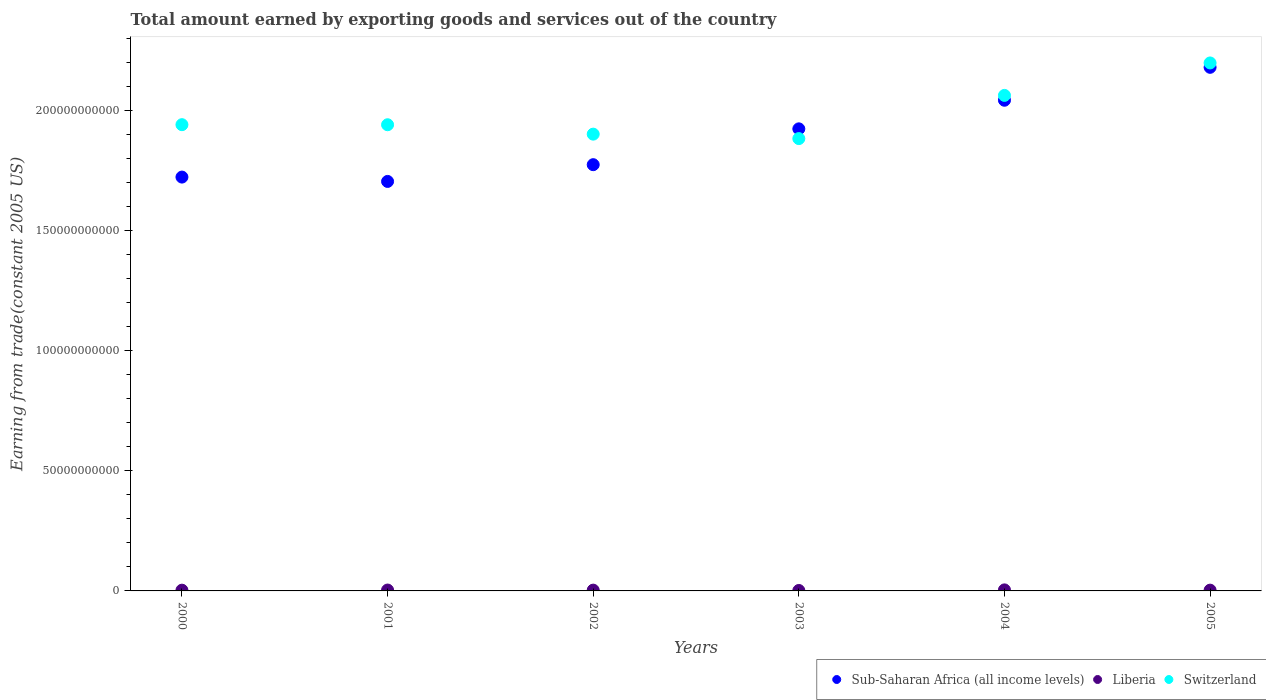What is the total amount earned by exporting goods and services in Switzerland in 2003?
Give a very brief answer. 1.88e+11. Across all years, what is the maximum total amount earned by exporting goods and services in Liberia?
Provide a short and direct response. 4.31e+08. Across all years, what is the minimum total amount earned by exporting goods and services in Switzerland?
Offer a very short reply. 1.88e+11. In which year was the total amount earned by exporting goods and services in Switzerland maximum?
Make the answer very short. 2005. In which year was the total amount earned by exporting goods and services in Switzerland minimum?
Keep it short and to the point. 2003. What is the total total amount earned by exporting goods and services in Liberia in the graph?
Offer a terse response. 1.95e+09. What is the difference between the total amount earned by exporting goods and services in Switzerland in 2002 and that in 2004?
Give a very brief answer. -1.61e+1. What is the difference between the total amount earned by exporting goods and services in Sub-Saharan Africa (all income levels) in 2001 and the total amount earned by exporting goods and services in Switzerland in 2000?
Your answer should be very brief. -2.36e+1. What is the average total amount earned by exporting goods and services in Sub-Saharan Africa (all income levels) per year?
Your answer should be compact. 1.89e+11. In the year 2001, what is the difference between the total amount earned by exporting goods and services in Liberia and total amount earned by exporting goods and services in Sub-Saharan Africa (all income levels)?
Your answer should be compact. -1.70e+11. In how many years, is the total amount earned by exporting goods and services in Sub-Saharan Africa (all income levels) greater than 60000000000 US$?
Keep it short and to the point. 6. What is the ratio of the total amount earned by exporting goods and services in Liberia in 2001 to that in 2003?
Provide a succinct answer. 1.96. Is the total amount earned by exporting goods and services in Liberia in 2002 less than that in 2005?
Your answer should be very brief. No. What is the difference between the highest and the second highest total amount earned by exporting goods and services in Sub-Saharan Africa (all income levels)?
Your answer should be very brief. 1.37e+1. What is the difference between the highest and the lowest total amount earned by exporting goods and services in Liberia?
Provide a short and direct response. 2.45e+08. Is the sum of the total amount earned by exporting goods and services in Switzerland in 2002 and 2004 greater than the maximum total amount earned by exporting goods and services in Sub-Saharan Africa (all income levels) across all years?
Your answer should be very brief. Yes. Does the total amount earned by exporting goods and services in Sub-Saharan Africa (all income levels) monotonically increase over the years?
Offer a very short reply. No. Is the total amount earned by exporting goods and services in Switzerland strictly greater than the total amount earned by exporting goods and services in Sub-Saharan Africa (all income levels) over the years?
Give a very brief answer. No. Is the total amount earned by exporting goods and services in Liberia strictly less than the total amount earned by exporting goods and services in Sub-Saharan Africa (all income levels) over the years?
Your response must be concise. Yes. What is the difference between two consecutive major ticks on the Y-axis?
Give a very brief answer. 5.00e+1. Where does the legend appear in the graph?
Keep it short and to the point. Bottom right. How many legend labels are there?
Give a very brief answer. 3. What is the title of the graph?
Provide a short and direct response. Total amount earned by exporting goods and services out of the country. Does "Philippines" appear as one of the legend labels in the graph?
Your answer should be compact. No. What is the label or title of the X-axis?
Your answer should be compact. Years. What is the label or title of the Y-axis?
Offer a terse response. Earning from trade(constant 2005 US). What is the Earning from trade(constant 2005 US) in Sub-Saharan Africa (all income levels) in 2000?
Provide a succinct answer. 1.72e+11. What is the Earning from trade(constant 2005 US) in Liberia in 2000?
Your answer should be very brief. 3.10e+08. What is the Earning from trade(constant 2005 US) in Switzerland in 2000?
Your response must be concise. 1.94e+11. What is the Earning from trade(constant 2005 US) of Sub-Saharan Africa (all income levels) in 2001?
Offer a terse response. 1.71e+11. What is the Earning from trade(constant 2005 US) of Liberia in 2001?
Your answer should be very brief. 3.65e+08. What is the Earning from trade(constant 2005 US) in Switzerland in 2001?
Provide a short and direct response. 1.94e+11. What is the Earning from trade(constant 2005 US) of Sub-Saharan Africa (all income levels) in 2002?
Your response must be concise. 1.77e+11. What is the Earning from trade(constant 2005 US) in Liberia in 2002?
Provide a succinct answer. 3.28e+08. What is the Earning from trade(constant 2005 US) in Switzerland in 2002?
Provide a succinct answer. 1.90e+11. What is the Earning from trade(constant 2005 US) of Sub-Saharan Africa (all income levels) in 2003?
Provide a succinct answer. 1.92e+11. What is the Earning from trade(constant 2005 US) of Liberia in 2003?
Provide a succinct answer. 1.86e+08. What is the Earning from trade(constant 2005 US) in Switzerland in 2003?
Give a very brief answer. 1.88e+11. What is the Earning from trade(constant 2005 US) of Sub-Saharan Africa (all income levels) in 2004?
Offer a terse response. 2.04e+11. What is the Earning from trade(constant 2005 US) of Liberia in 2004?
Your response must be concise. 4.31e+08. What is the Earning from trade(constant 2005 US) of Switzerland in 2004?
Offer a very short reply. 2.06e+11. What is the Earning from trade(constant 2005 US) of Sub-Saharan Africa (all income levels) in 2005?
Provide a succinct answer. 2.18e+11. What is the Earning from trade(constant 2005 US) of Liberia in 2005?
Offer a terse response. 3.25e+08. What is the Earning from trade(constant 2005 US) of Switzerland in 2005?
Provide a short and direct response. 2.20e+11. Across all years, what is the maximum Earning from trade(constant 2005 US) of Sub-Saharan Africa (all income levels)?
Provide a succinct answer. 2.18e+11. Across all years, what is the maximum Earning from trade(constant 2005 US) in Liberia?
Ensure brevity in your answer.  4.31e+08. Across all years, what is the maximum Earning from trade(constant 2005 US) of Switzerland?
Ensure brevity in your answer.  2.20e+11. Across all years, what is the minimum Earning from trade(constant 2005 US) in Sub-Saharan Africa (all income levels)?
Make the answer very short. 1.71e+11. Across all years, what is the minimum Earning from trade(constant 2005 US) of Liberia?
Provide a succinct answer. 1.86e+08. Across all years, what is the minimum Earning from trade(constant 2005 US) of Switzerland?
Keep it short and to the point. 1.88e+11. What is the total Earning from trade(constant 2005 US) of Sub-Saharan Africa (all income levels) in the graph?
Keep it short and to the point. 1.14e+12. What is the total Earning from trade(constant 2005 US) in Liberia in the graph?
Provide a succinct answer. 1.95e+09. What is the total Earning from trade(constant 2005 US) in Switzerland in the graph?
Your response must be concise. 1.19e+12. What is the difference between the Earning from trade(constant 2005 US) of Sub-Saharan Africa (all income levels) in 2000 and that in 2001?
Provide a short and direct response. 1.81e+09. What is the difference between the Earning from trade(constant 2005 US) of Liberia in 2000 and that in 2001?
Make the answer very short. -5.56e+07. What is the difference between the Earning from trade(constant 2005 US) in Switzerland in 2000 and that in 2001?
Offer a very short reply. 2.98e+07. What is the difference between the Earning from trade(constant 2005 US) of Sub-Saharan Africa (all income levels) in 2000 and that in 2002?
Your response must be concise. -5.17e+09. What is the difference between the Earning from trade(constant 2005 US) in Liberia in 2000 and that in 2002?
Keep it short and to the point. -1.86e+07. What is the difference between the Earning from trade(constant 2005 US) of Switzerland in 2000 and that in 2002?
Keep it short and to the point. 3.94e+09. What is the difference between the Earning from trade(constant 2005 US) in Sub-Saharan Africa (all income levels) in 2000 and that in 2003?
Ensure brevity in your answer.  -2.01e+1. What is the difference between the Earning from trade(constant 2005 US) of Liberia in 2000 and that in 2003?
Provide a short and direct response. 1.24e+08. What is the difference between the Earning from trade(constant 2005 US) of Switzerland in 2000 and that in 2003?
Your response must be concise. 5.79e+09. What is the difference between the Earning from trade(constant 2005 US) in Sub-Saharan Africa (all income levels) in 2000 and that in 2004?
Make the answer very short. -3.20e+1. What is the difference between the Earning from trade(constant 2005 US) in Liberia in 2000 and that in 2004?
Ensure brevity in your answer.  -1.21e+08. What is the difference between the Earning from trade(constant 2005 US) of Switzerland in 2000 and that in 2004?
Provide a succinct answer. -1.22e+1. What is the difference between the Earning from trade(constant 2005 US) of Sub-Saharan Africa (all income levels) in 2000 and that in 2005?
Give a very brief answer. -4.57e+1. What is the difference between the Earning from trade(constant 2005 US) in Liberia in 2000 and that in 2005?
Provide a succinct answer. -1.52e+07. What is the difference between the Earning from trade(constant 2005 US) of Switzerland in 2000 and that in 2005?
Your answer should be very brief. -2.57e+1. What is the difference between the Earning from trade(constant 2005 US) in Sub-Saharan Africa (all income levels) in 2001 and that in 2002?
Ensure brevity in your answer.  -6.98e+09. What is the difference between the Earning from trade(constant 2005 US) of Liberia in 2001 and that in 2002?
Provide a short and direct response. 3.70e+07. What is the difference between the Earning from trade(constant 2005 US) of Switzerland in 2001 and that in 2002?
Your response must be concise. 3.91e+09. What is the difference between the Earning from trade(constant 2005 US) in Sub-Saharan Africa (all income levels) in 2001 and that in 2003?
Your response must be concise. -2.19e+1. What is the difference between the Earning from trade(constant 2005 US) of Liberia in 2001 and that in 2003?
Your response must be concise. 1.79e+08. What is the difference between the Earning from trade(constant 2005 US) of Switzerland in 2001 and that in 2003?
Offer a terse response. 5.76e+09. What is the difference between the Earning from trade(constant 2005 US) of Sub-Saharan Africa (all income levels) in 2001 and that in 2004?
Keep it short and to the point. -3.38e+1. What is the difference between the Earning from trade(constant 2005 US) of Liberia in 2001 and that in 2004?
Your answer should be compact. -6.53e+07. What is the difference between the Earning from trade(constant 2005 US) of Switzerland in 2001 and that in 2004?
Provide a succinct answer. -1.22e+1. What is the difference between the Earning from trade(constant 2005 US) in Sub-Saharan Africa (all income levels) in 2001 and that in 2005?
Ensure brevity in your answer.  -4.75e+1. What is the difference between the Earning from trade(constant 2005 US) in Liberia in 2001 and that in 2005?
Offer a terse response. 4.04e+07. What is the difference between the Earning from trade(constant 2005 US) of Switzerland in 2001 and that in 2005?
Provide a short and direct response. -2.57e+1. What is the difference between the Earning from trade(constant 2005 US) of Sub-Saharan Africa (all income levels) in 2002 and that in 2003?
Offer a terse response. -1.49e+1. What is the difference between the Earning from trade(constant 2005 US) of Liberia in 2002 and that in 2003?
Ensure brevity in your answer.  1.42e+08. What is the difference between the Earning from trade(constant 2005 US) in Switzerland in 2002 and that in 2003?
Make the answer very short. 1.85e+09. What is the difference between the Earning from trade(constant 2005 US) in Sub-Saharan Africa (all income levels) in 2002 and that in 2004?
Make the answer very short. -2.68e+1. What is the difference between the Earning from trade(constant 2005 US) of Liberia in 2002 and that in 2004?
Ensure brevity in your answer.  -1.02e+08. What is the difference between the Earning from trade(constant 2005 US) in Switzerland in 2002 and that in 2004?
Offer a terse response. -1.61e+1. What is the difference between the Earning from trade(constant 2005 US) in Sub-Saharan Africa (all income levels) in 2002 and that in 2005?
Give a very brief answer. -4.05e+1. What is the difference between the Earning from trade(constant 2005 US) of Liberia in 2002 and that in 2005?
Your answer should be very brief. 3.39e+06. What is the difference between the Earning from trade(constant 2005 US) in Switzerland in 2002 and that in 2005?
Provide a short and direct response. -2.96e+1. What is the difference between the Earning from trade(constant 2005 US) in Sub-Saharan Africa (all income levels) in 2003 and that in 2004?
Provide a short and direct response. -1.19e+1. What is the difference between the Earning from trade(constant 2005 US) in Liberia in 2003 and that in 2004?
Ensure brevity in your answer.  -2.45e+08. What is the difference between the Earning from trade(constant 2005 US) in Switzerland in 2003 and that in 2004?
Offer a terse response. -1.80e+1. What is the difference between the Earning from trade(constant 2005 US) in Sub-Saharan Africa (all income levels) in 2003 and that in 2005?
Keep it short and to the point. -2.56e+1. What is the difference between the Earning from trade(constant 2005 US) of Liberia in 2003 and that in 2005?
Offer a terse response. -1.39e+08. What is the difference between the Earning from trade(constant 2005 US) in Switzerland in 2003 and that in 2005?
Keep it short and to the point. -3.15e+1. What is the difference between the Earning from trade(constant 2005 US) in Sub-Saharan Africa (all income levels) in 2004 and that in 2005?
Your answer should be very brief. -1.37e+1. What is the difference between the Earning from trade(constant 2005 US) of Liberia in 2004 and that in 2005?
Ensure brevity in your answer.  1.06e+08. What is the difference between the Earning from trade(constant 2005 US) of Switzerland in 2004 and that in 2005?
Give a very brief answer. -1.35e+1. What is the difference between the Earning from trade(constant 2005 US) in Sub-Saharan Africa (all income levels) in 2000 and the Earning from trade(constant 2005 US) in Liberia in 2001?
Keep it short and to the point. 1.72e+11. What is the difference between the Earning from trade(constant 2005 US) of Sub-Saharan Africa (all income levels) in 2000 and the Earning from trade(constant 2005 US) of Switzerland in 2001?
Your answer should be compact. -2.18e+1. What is the difference between the Earning from trade(constant 2005 US) of Liberia in 2000 and the Earning from trade(constant 2005 US) of Switzerland in 2001?
Your answer should be compact. -1.94e+11. What is the difference between the Earning from trade(constant 2005 US) of Sub-Saharan Africa (all income levels) in 2000 and the Earning from trade(constant 2005 US) of Liberia in 2002?
Give a very brief answer. 1.72e+11. What is the difference between the Earning from trade(constant 2005 US) in Sub-Saharan Africa (all income levels) in 2000 and the Earning from trade(constant 2005 US) in Switzerland in 2002?
Keep it short and to the point. -1.79e+1. What is the difference between the Earning from trade(constant 2005 US) of Liberia in 2000 and the Earning from trade(constant 2005 US) of Switzerland in 2002?
Offer a very short reply. -1.90e+11. What is the difference between the Earning from trade(constant 2005 US) of Sub-Saharan Africa (all income levels) in 2000 and the Earning from trade(constant 2005 US) of Liberia in 2003?
Provide a succinct answer. 1.72e+11. What is the difference between the Earning from trade(constant 2005 US) of Sub-Saharan Africa (all income levels) in 2000 and the Earning from trade(constant 2005 US) of Switzerland in 2003?
Give a very brief answer. -1.60e+1. What is the difference between the Earning from trade(constant 2005 US) of Liberia in 2000 and the Earning from trade(constant 2005 US) of Switzerland in 2003?
Your response must be concise. -1.88e+11. What is the difference between the Earning from trade(constant 2005 US) of Sub-Saharan Africa (all income levels) in 2000 and the Earning from trade(constant 2005 US) of Liberia in 2004?
Offer a very short reply. 1.72e+11. What is the difference between the Earning from trade(constant 2005 US) of Sub-Saharan Africa (all income levels) in 2000 and the Earning from trade(constant 2005 US) of Switzerland in 2004?
Give a very brief answer. -3.40e+1. What is the difference between the Earning from trade(constant 2005 US) in Liberia in 2000 and the Earning from trade(constant 2005 US) in Switzerland in 2004?
Your response must be concise. -2.06e+11. What is the difference between the Earning from trade(constant 2005 US) in Sub-Saharan Africa (all income levels) in 2000 and the Earning from trade(constant 2005 US) in Liberia in 2005?
Make the answer very short. 1.72e+11. What is the difference between the Earning from trade(constant 2005 US) in Sub-Saharan Africa (all income levels) in 2000 and the Earning from trade(constant 2005 US) in Switzerland in 2005?
Your answer should be compact. -4.75e+1. What is the difference between the Earning from trade(constant 2005 US) in Liberia in 2000 and the Earning from trade(constant 2005 US) in Switzerland in 2005?
Provide a short and direct response. -2.20e+11. What is the difference between the Earning from trade(constant 2005 US) in Sub-Saharan Africa (all income levels) in 2001 and the Earning from trade(constant 2005 US) in Liberia in 2002?
Ensure brevity in your answer.  1.70e+11. What is the difference between the Earning from trade(constant 2005 US) of Sub-Saharan Africa (all income levels) in 2001 and the Earning from trade(constant 2005 US) of Switzerland in 2002?
Give a very brief answer. -1.97e+1. What is the difference between the Earning from trade(constant 2005 US) in Liberia in 2001 and the Earning from trade(constant 2005 US) in Switzerland in 2002?
Offer a terse response. -1.90e+11. What is the difference between the Earning from trade(constant 2005 US) of Sub-Saharan Africa (all income levels) in 2001 and the Earning from trade(constant 2005 US) of Liberia in 2003?
Provide a short and direct response. 1.70e+11. What is the difference between the Earning from trade(constant 2005 US) in Sub-Saharan Africa (all income levels) in 2001 and the Earning from trade(constant 2005 US) in Switzerland in 2003?
Make the answer very short. -1.78e+1. What is the difference between the Earning from trade(constant 2005 US) of Liberia in 2001 and the Earning from trade(constant 2005 US) of Switzerland in 2003?
Your answer should be very brief. -1.88e+11. What is the difference between the Earning from trade(constant 2005 US) of Sub-Saharan Africa (all income levels) in 2001 and the Earning from trade(constant 2005 US) of Liberia in 2004?
Your response must be concise. 1.70e+11. What is the difference between the Earning from trade(constant 2005 US) of Sub-Saharan Africa (all income levels) in 2001 and the Earning from trade(constant 2005 US) of Switzerland in 2004?
Your response must be concise. -3.58e+1. What is the difference between the Earning from trade(constant 2005 US) in Liberia in 2001 and the Earning from trade(constant 2005 US) in Switzerland in 2004?
Your answer should be very brief. -2.06e+11. What is the difference between the Earning from trade(constant 2005 US) of Sub-Saharan Africa (all income levels) in 2001 and the Earning from trade(constant 2005 US) of Liberia in 2005?
Keep it short and to the point. 1.70e+11. What is the difference between the Earning from trade(constant 2005 US) in Sub-Saharan Africa (all income levels) in 2001 and the Earning from trade(constant 2005 US) in Switzerland in 2005?
Provide a succinct answer. -4.93e+1. What is the difference between the Earning from trade(constant 2005 US) of Liberia in 2001 and the Earning from trade(constant 2005 US) of Switzerland in 2005?
Offer a very short reply. -2.19e+11. What is the difference between the Earning from trade(constant 2005 US) of Sub-Saharan Africa (all income levels) in 2002 and the Earning from trade(constant 2005 US) of Liberia in 2003?
Offer a very short reply. 1.77e+11. What is the difference between the Earning from trade(constant 2005 US) of Sub-Saharan Africa (all income levels) in 2002 and the Earning from trade(constant 2005 US) of Switzerland in 2003?
Give a very brief answer. -1.09e+1. What is the difference between the Earning from trade(constant 2005 US) of Liberia in 2002 and the Earning from trade(constant 2005 US) of Switzerland in 2003?
Provide a succinct answer. -1.88e+11. What is the difference between the Earning from trade(constant 2005 US) in Sub-Saharan Africa (all income levels) in 2002 and the Earning from trade(constant 2005 US) in Liberia in 2004?
Your answer should be compact. 1.77e+11. What is the difference between the Earning from trade(constant 2005 US) of Sub-Saharan Africa (all income levels) in 2002 and the Earning from trade(constant 2005 US) of Switzerland in 2004?
Keep it short and to the point. -2.88e+1. What is the difference between the Earning from trade(constant 2005 US) in Liberia in 2002 and the Earning from trade(constant 2005 US) in Switzerland in 2004?
Offer a very short reply. -2.06e+11. What is the difference between the Earning from trade(constant 2005 US) in Sub-Saharan Africa (all income levels) in 2002 and the Earning from trade(constant 2005 US) in Liberia in 2005?
Provide a short and direct response. 1.77e+11. What is the difference between the Earning from trade(constant 2005 US) in Sub-Saharan Africa (all income levels) in 2002 and the Earning from trade(constant 2005 US) in Switzerland in 2005?
Make the answer very short. -4.24e+1. What is the difference between the Earning from trade(constant 2005 US) in Liberia in 2002 and the Earning from trade(constant 2005 US) in Switzerland in 2005?
Your answer should be compact. -2.20e+11. What is the difference between the Earning from trade(constant 2005 US) in Sub-Saharan Africa (all income levels) in 2003 and the Earning from trade(constant 2005 US) in Liberia in 2004?
Your response must be concise. 1.92e+11. What is the difference between the Earning from trade(constant 2005 US) of Sub-Saharan Africa (all income levels) in 2003 and the Earning from trade(constant 2005 US) of Switzerland in 2004?
Your answer should be very brief. -1.39e+1. What is the difference between the Earning from trade(constant 2005 US) in Liberia in 2003 and the Earning from trade(constant 2005 US) in Switzerland in 2004?
Offer a very short reply. -2.06e+11. What is the difference between the Earning from trade(constant 2005 US) in Sub-Saharan Africa (all income levels) in 2003 and the Earning from trade(constant 2005 US) in Liberia in 2005?
Give a very brief answer. 1.92e+11. What is the difference between the Earning from trade(constant 2005 US) of Sub-Saharan Africa (all income levels) in 2003 and the Earning from trade(constant 2005 US) of Switzerland in 2005?
Make the answer very short. -2.74e+1. What is the difference between the Earning from trade(constant 2005 US) of Liberia in 2003 and the Earning from trade(constant 2005 US) of Switzerland in 2005?
Your answer should be very brief. -2.20e+11. What is the difference between the Earning from trade(constant 2005 US) in Sub-Saharan Africa (all income levels) in 2004 and the Earning from trade(constant 2005 US) in Liberia in 2005?
Make the answer very short. 2.04e+11. What is the difference between the Earning from trade(constant 2005 US) in Sub-Saharan Africa (all income levels) in 2004 and the Earning from trade(constant 2005 US) in Switzerland in 2005?
Make the answer very short. -1.55e+1. What is the difference between the Earning from trade(constant 2005 US) of Liberia in 2004 and the Earning from trade(constant 2005 US) of Switzerland in 2005?
Your answer should be compact. -2.19e+11. What is the average Earning from trade(constant 2005 US) in Sub-Saharan Africa (all income levels) per year?
Keep it short and to the point. 1.89e+11. What is the average Earning from trade(constant 2005 US) of Liberia per year?
Your answer should be very brief. 3.24e+08. What is the average Earning from trade(constant 2005 US) in Switzerland per year?
Your answer should be compact. 1.99e+11. In the year 2000, what is the difference between the Earning from trade(constant 2005 US) in Sub-Saharan Africa (all income levels) and Earning from trade(constant 2005 US) in Liberia?
Your answer should be very brief. 1.72e+11. In the year 2000, what is the difference between the Earning from trade(constant 2005 US) in Sub-Saharan Africa (all income levels) and Earning from trade(constant 2005 US) in Switzerland?
Offer a very short reply. -2.18e+1. In the year 2000, what is the difference between the Earning from trade(constant 2005 US) in Liberia and Earning from trade(constant 2005 US) in Switzerland?
Keep it short and to the point. -1.94e+11. In the year 2001, what is the difference between the Earning from trade(constant 2005 US) of Sub-Saharan Africa (all income levels) and Earning from trade(constant 2005 US) of Liberia?
Make the answer very short. 1.70e+11. In the year 2001, what is the difference between the Earning from trade(constant 2005 US) of Sub-Saharan Africa (all income levels) and Earning from trade(constant 2005 US) of Switzerland?
Give a very brief answer. -2.36e+1. In the year 2001, what is the difference between the Earning from trade(constant 2005 US) in Liberia and Earning from trade(constant 2005 US) in Switzerland?
Ensure brevity in your answer.  -1.94e+11. In the year 2002, what is the difference between the Earning from trade(constant 2005 US) in Sub-Saharan Africa (all income levels) and Earning from trade(constant 2005 US) in Liberia?
Ensure brevity in your answer.  1.77e+11. In the year 2002, what is the difference between the Earning from trade(constant 2005 US) of Sub-Saharan Africa (all income levels) and Earning from trade(constant 2005 US) of Switzerland?
Keep it short and to the point. -1.27e+1. In the year 2002, what is the difference between the Earning from trade(constant 2005 US) of Liberia and Earning from trade(constant 2005 US) of Switzerland?
Your answer should be compact. -1.90e+11. In the year 2003, what is the difference between the Earning from trade(constant 2005 US) of Sub-Saharan Africa (all income levels) and Earning from trade(constant 2005 US) of Liberia?
Make the answer very short. 1.92e+11. In the year 2003, what is the difference between the Earning from trade(constant 2005 US) in Sub-Saharan Africa (all income levels) and Earning from trade(constant 2005 US) in Switzerland?
Give a very brief answer. 4.05e+09. In the year 2003, what is the difference between the Earning from trade(constant 2005 US) of Liberia and Earning from trade(constant 2005 US) of Switzerland?
Your answer should be very brief. -1.88e+11. In the year 2004, what is the difference between the Earning from trade(constant 2005 US) of Sub-Saharan Africa (all income levels) and Earning from trade(constant 2005 US) of Liberia?
Provide a short and direct response. 2.04e+11. In the year 2004, what is the difference between the Earning from trade(constant 2005 US) of Sub-Saharan Africa (all income levels) and Earning from trade(constant 2005 US) of Switzerland?
Your response must be concise. -2.02e+09. In the year 2004, what is the difference between the Earning from trade(constant 2005 US) in Liberia and Earning from trade(constant 2005 US) in Switzerland?
Ensure brevity in your answer.  -2.06e+11. In the year 2005, what is the difference between the Earning from trade(constant 2005 US) of Sub-Saharan Africa (all income levels) and Earning from trade(constant 2005 US) of Liberia?
Your answer should be compact. 2.18e+11. In the year 2005, what is the difference between the Earning from trade(constant 2005 US) in Sub-Saharan Africa (all income levels) and Earning from trade(constant 2005 US) in Switzerland?
Provide a short and direct response. -1.82e+09. In the year 2005, what is the difference between the Earning from trade(constant 2005 US) of Liberia and Earning from trade(constant 2005 US) of Switzerland?
Make the answer very short. -2.20e+11. What is the ratio of the Earning from trade(constant 2005 US) of Sub-Saharan Africa (all income levels) in 2000 to that in 2001?
Your response must be concise. 1.01. What is the ratio of the Earning from trade(constant 2005 US) of Liberia in 2000 to that in 2001?
Provide a succinct answer. 0.85. What is the ratio of the Earning from trade(constant 2005 US) of Sub-Saharan Africa (all income levels) in 2000 to that in 2002?
Provide a short and direct response. 0.97. What is the ratio of the Earning from trade(constant 2005 US) of Liberia in 2000 to that in 2002?
Ensure brevity in your answer.  0.94. What is the ratio of the Earning from trade(constant 2005 US) of Switzerland in 2000 to that in 2002?
Your answer should be compact. 1.02. What is the ratio of the Earning from trade(constant 2005 US) of Sub-Saharan Africa (all income levels) in 2000 to that in 2003?
Keep it short and to the point. 0.9. What is the ratio of the Earning from trade(constant 2005 US) in Liberia in 2000 to that in 2003?
Make the answer very short. 1.67. What is the ratio of the Earning from trade(constant 2005 US) of Switzerland in 2000 to that in 2003?
Give a very brief answer. 1.03. What is the ratio of the Earning from trade(constant 2005 US) in Sub-Saharan Africa (all income levels) in 2000 to that in 2004?
Your answer should be compact. 0.84. What is the ratio of the Earning from trade(constant 2005 US) of Liberia in 2000 to that in 2004?
Offer a very short reply. 0.72. What is the ratio of the Earning from trade(constant 2005 US) of Switzerland in 2000 to that in 2004?
Keep it short and to the point. 0.94. What is the ratio of the Earning from trade(constant 2005 US) in Sub-Saharan Africa (all income levels) in 2000 to that in 2005?
Your answer should be compact. 0.79. What is the ratio of the Earning from trade(constant 2005 US) in Liberia in 2000 to that in 2005?
Offer a very short reply. 0.95. What is the ratio of the Earning from trade(constant 2005 US) of Switzerland in 2000 to that in 2005?
Provide a short and direct response. 0.88. What is the ratio of the Earning from trade(constant 2005 US) of Sub-Saharan Africa (all income levels) in 2001 to that in 2002?
Give a very brief answer. 0.96. What is the ratio of the Earning from trade(constant 2005 US) in Liberia in 2001 to that in 2002?
Your response must be concise. 1.11. What is the ratio of the Earning from trade(constant 2005 US) of Switzerland in 2001 to that in 2002?
Provide a short and direct response. 1.02. What is the ratio of the Earning from trade(constant 2005 US) in Sub-Saharan Africa (all income levels) in 2001 to that in 2003?
Offer a terse response. 0.89. What is the ratio of the Earning from trade(constant 2005 US) in Liberia in 2001 to that in 2003?
Offer a very short reply. 1.96. What is the ratio of the Earning from trade(constant 2005 US) in Switzerland in 2001 to that in 2003?
Your answer should be very brief. 1.03. What is the ratio of the Earning from trade(constant 2005 US) in Sub-Saharan Africa (all income levels) in 2001 to that in 2004?
Offer a terse response. 0.83. What is the ratio of the Earning from trade(constant 2005 US) in Liberia in 2001 to that in 2004?
Make the answer very short. 0.85. What is the ratio of the Earning from trade(constant 2005 US) of Switzerland in 2001 to that in 2004?
Your response must be concise. 0.94. What is the ratio of the Earning from trade(constant 2005 US) of Sub-Saharan Africa (all income levels) in 2001 to that in 2005?
Offer a terse response. 0.78. What is the ratio of the Earning from trade(constant 2005 US) of Liberia in 2001 to that in 2005?
Your answer should be compact. 1.12. What is the ratio of the Earning from trade(constant 2005 US) in Switzerland in 2001 to that in 2005?
Your answer should be very brief. 0.88. What is the ratio of the Earning from trade(constant 2005 US) in Sub-Saharan Africa (all income levels) in 2002 to that in 2003?
Your answer should be compact. 0.92. What is the ratio of the Earning from trade(constant 2005 US) in Liberia in 2002 to that in 2003?
Keep it short and to the point. 1.77. What is the ratio of the Earning from trade(constant 2005 US) of Switzerland in 2002 to that in 2003?
Your answer should be very brief. 1.01. What is the ratio of the Earning from trade(constant 2005 US) in Sub-Saharan Africa (all income levels) in 2002 to that in 2004?
Offer a very short reply. 0.87. What is the ratio of the Earning from trade(constant 2005 US) in Liberia in 2002 to that in 2004?
Your response must be concise. 0.76. What is the ratio of the Earning from trade(constant 2005 US) in Switzerland in 2002 to that in 2004?
Give a very brief answer. 0.92. What is the ratio of the Earning from trade(constant 2005 US) of Sub-Saharan Africa (all income levels) in 2002 to that in 2005?
Provide a succinct answer. 0.81. What is the ratio of the Earning from trade(constant 2005 US) of Liberia in 2002 to that in 2005?
Offer a very short reply. 1.01. What is the ratio of the Earning from trade(constant 2005 US) of Switzerland in 2002 to that in 2005?
Make the answer very short. 0.87. What is the ratio of the Earning from trade(constant 2005 US) of Sub-Saharan Africa (all income levels) in 2003 to that in 2004?
Make the answer very short. 0.94. What is the ratio of the Earning from trade(constant 2005 US) in Liberia in 2003 to that in 2004?
Offer a very short reply. 0.43. What is the ratio of the Earning from trade(constant 2005 US) of Switzerland in 2003 to that in 2004?
Provide a short and direct response. 0.91. What is the ratio of the Earning from trade(constant 2005 US) in Sub-Saharan Africa (all income levels) in 2003 to that in 2005?
Give a very brief answer. 0.88. What is the ratio of the Earning from trade(constant 2005 US) in Liberia in 2003 to that in 2005?
Provide a succinct answer. 0.57. What is the ratio of the Earning from trade(constant 2005 US) in Switzerland in 2003 to that in 2005?
Provide a succinct answer. 0.86. What is the ratio of the Earning from trade(constant 2005 US) of Sub-Saharan Africa (all income levels) in 2004 to that in 2005?
Your response must be concise. 0.94. What is the ratio of the Earning from trade(constant 2005 US) in Liberia in 2004 to that in 2005?
Keep it short and to the point. 1.33. What is the ratio of the Earning from trade(constant 2005 US) of Switzerland in 2004 to that in 2005?
Your answer should be compact. 0.94. What is the difference between the highest and the second highest Earning from trade(constant 2005 US) in Sub-Saharan Africa (all income levels)?
Offer a terse response. 1.37e+1. What is the difference between the highest and the second highest Earning from trade(constant 2005 US) of Liberia?
Provide a succinct answer. 6.53e+07. What is the difference between the highest and the second highest Earning from trade(constant 2005 US) in Switzerland?
Keep it short and to the point. 1.35e+1. What is the difference between the highest and the lowest Earning from trade(constant 2005 US) in Sub-Saharan Africa (all income levels)?
Give a very brief answer. 4.75e+1. What is the difference between the highest and the lowest Earning from trade(constant 2005 US) in Liberia?
Offer a very short reply. 2.45e+08. What is the difference between the highest and the lowest Earning from trade(constant 2005 US) of Switzerland?
Your response must be concise. 3.15e+1. 